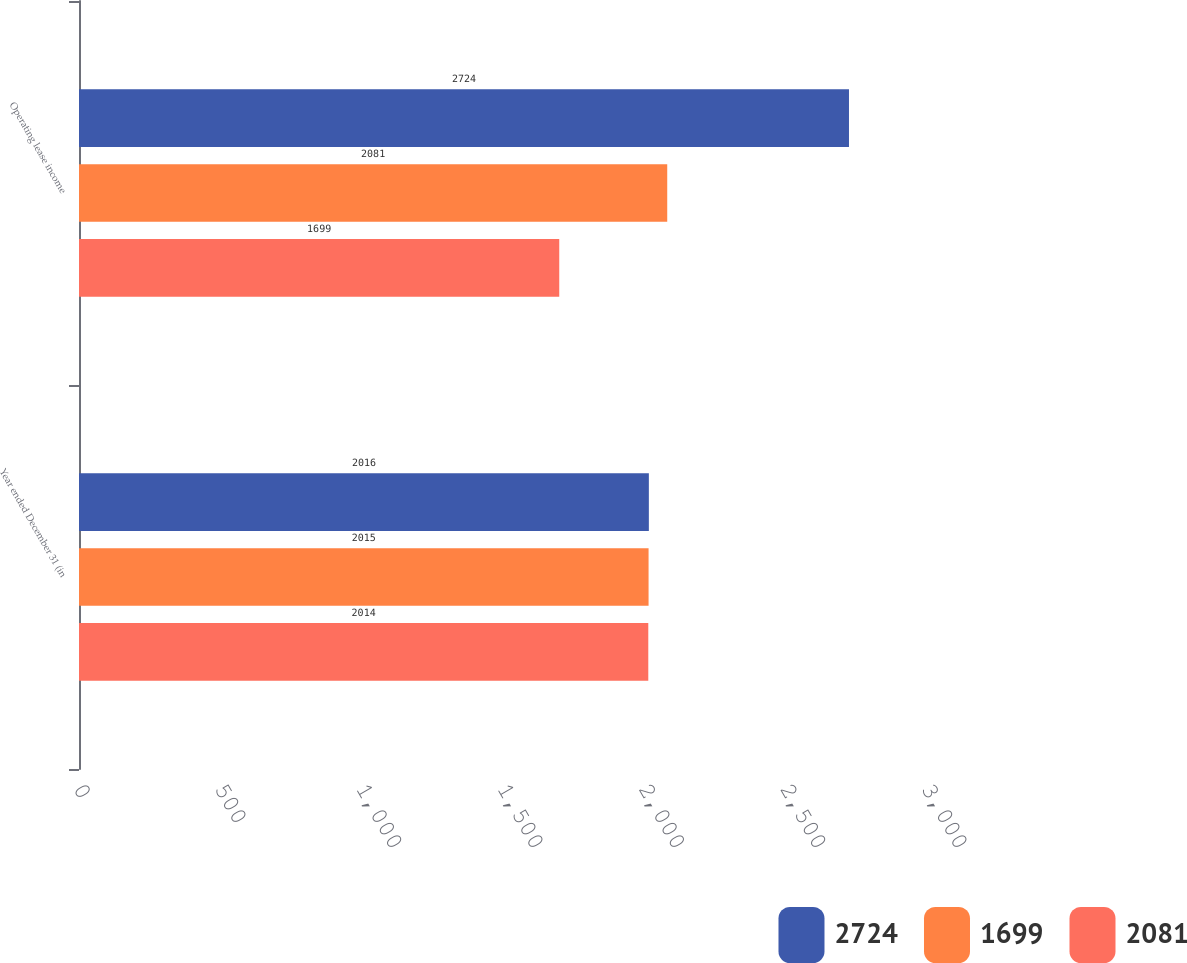Convert chart to OTSL. <chart><loc_0><loc_0><loc_500><loc_500><stacked_bar_chart><ecel><fcel>Year ended December 31 (in<fcel>Operating lease income<nl><fcel>2724<fcel>2016<fcel>2724<nl><fcel>1699<fcel>2015<fcel>2081<nl><fcel>2081<fcel>2014<fcel>1699<nl></chart> 